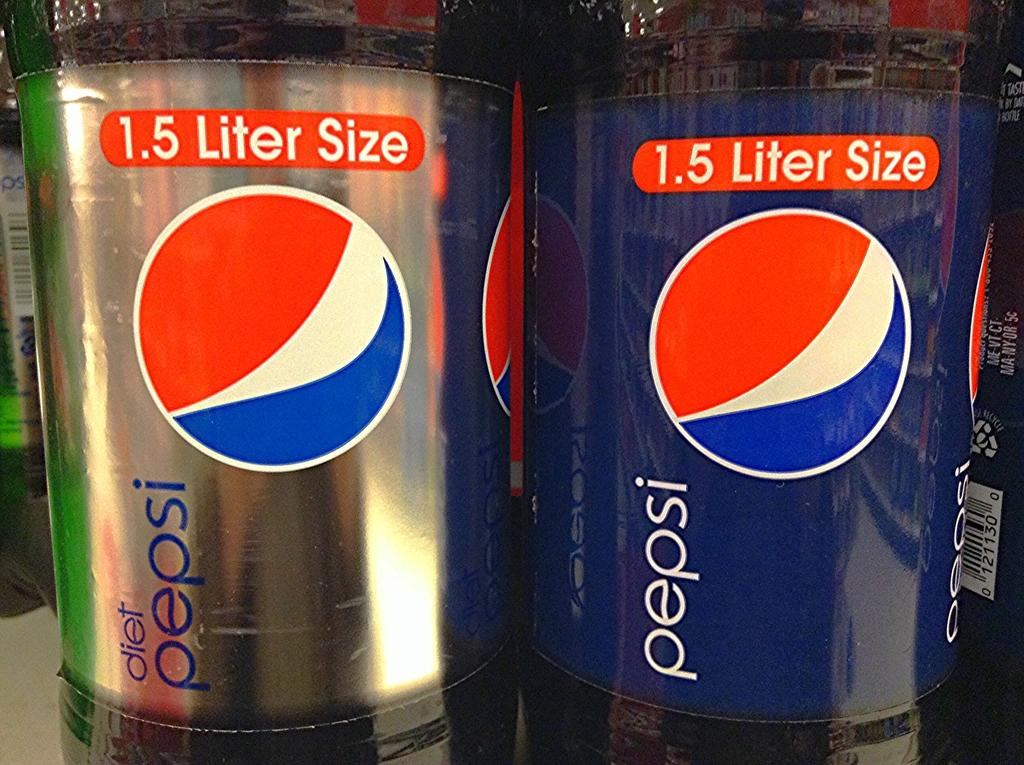What objects can be seen in the image? There are bottles in the image. What distinguishing features do the bottles have? The bottles have labels. What information can be found on the labels? The labels contain logos and text. What type of leather material is used to make the labels on the bottles? There is no leather material present on the labels of the bottles; they are made of paper or another labeling material. 